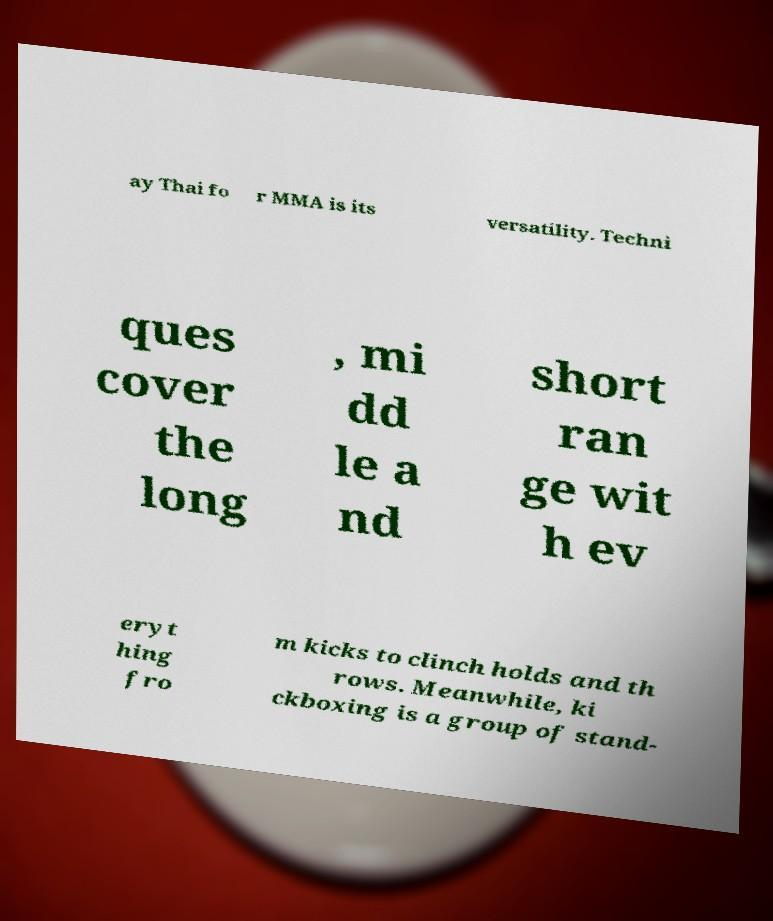What messages or text are displayed in this image? I need them in a readable, typed format. ay Thai fo r MMA is its versatility. Techni ques cover the long , mi dd le a nd short ran ge wit h ev eryt hing fro m kicks to clinch holds and th rows. Meanwhile, ki ckboxing is a group of stand- 